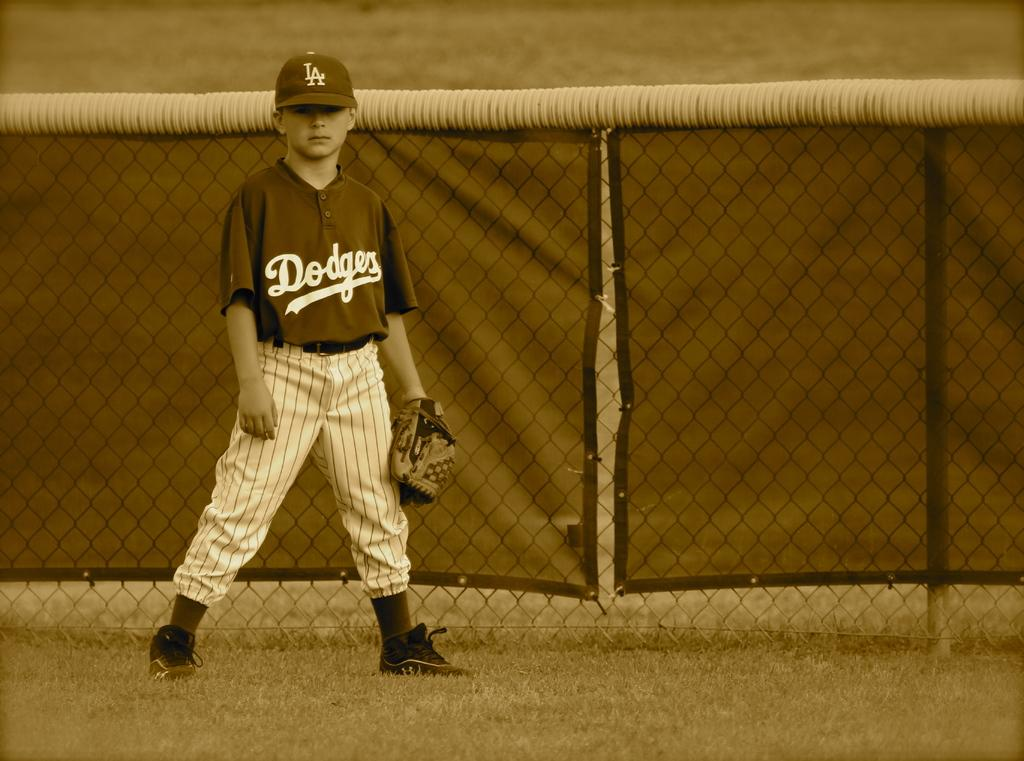<image>
Write a terse but informative summary of the picture. A little boy in a baseball uniform that has LA Dodgers on it 